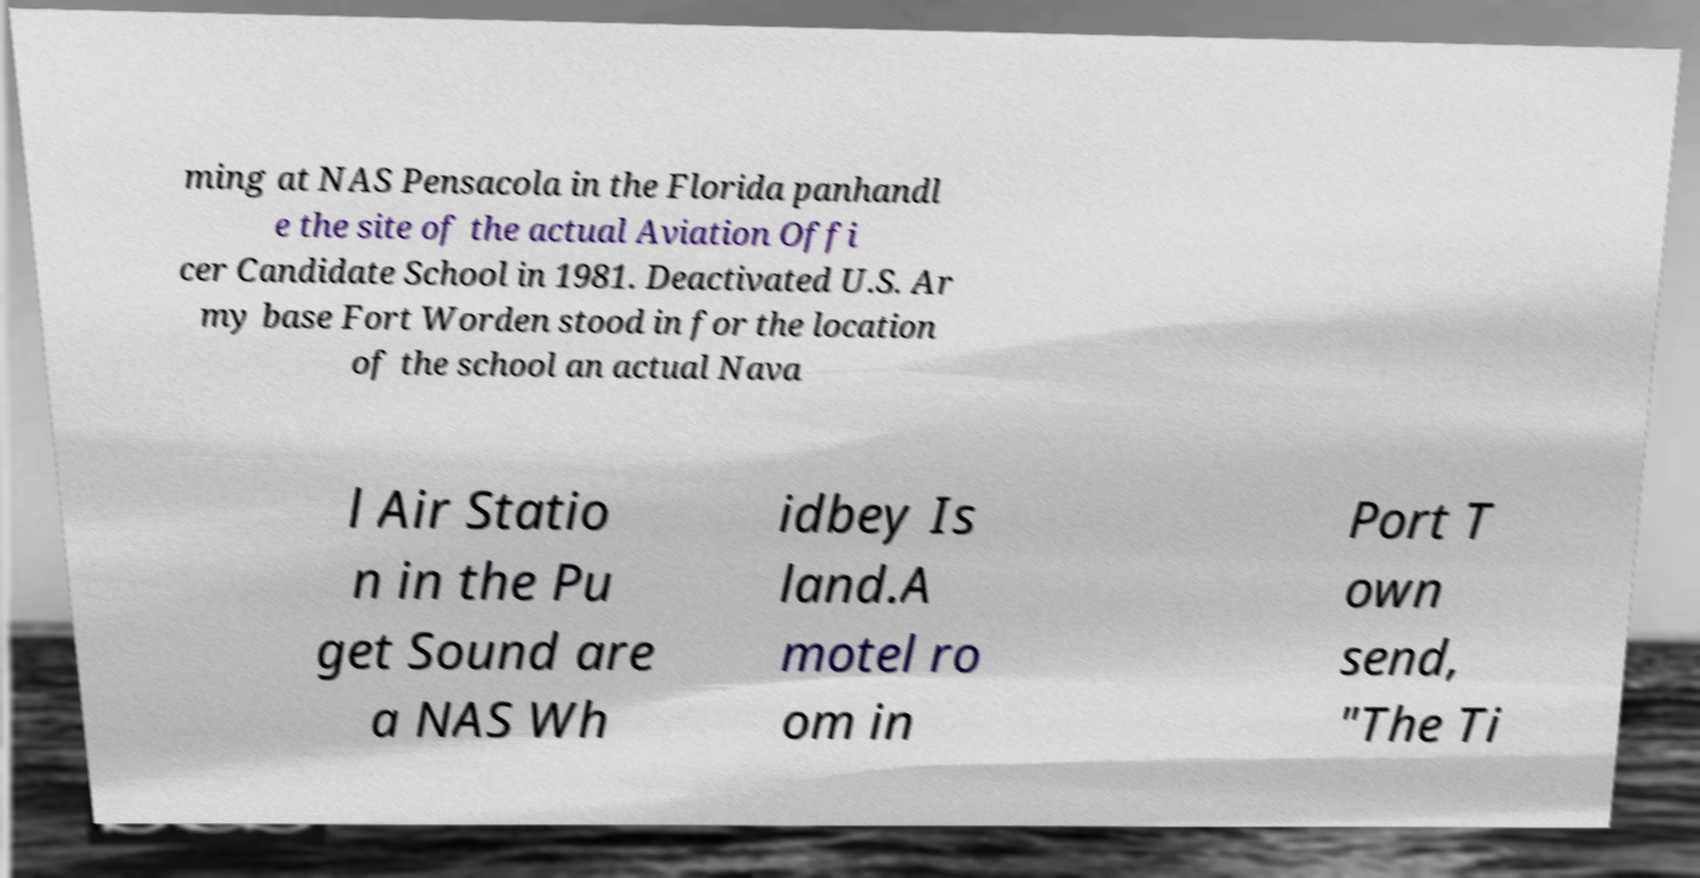Can you read and provide the text displayed in the image?This photo seems to have some interesting text. Can you extract and type it out for me? ming at NAS Pensacola in the Florida panhandl e the site of the actual Aviation Offi cer Candidate School in 1981. Deactivated U.S. Ar my base Fort Worden stood in for the location of the school an actual Nava l Air Statio n in the Pu get Sound are a NAS Wh idbey Is land.A motel ro om in Port T own send, "The Ti 